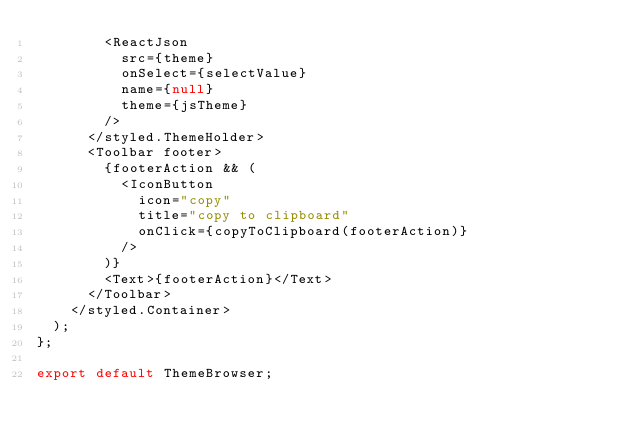Convert code to text. <code><loc_0><loc_0><loc_500><loc_500><_JavaScript_>        <ReactJson
          src={theme}
          onSelect={selectValue}
          name={null}
          theme={jsTheme}
        />
      </styled.ThemeHolder>
      <Toolbar footer>
        {footerAction && (
          <IconButton
            icon="copy"
            title="copy to clipboard"
            onClick={copyToClipboard(footerAction)}
          />
        )}
        <Text>{footerAction}</Text>
      </Toolbar>
    </styled.Container>
  );
};

export default ThemeBrowser;
</code> 